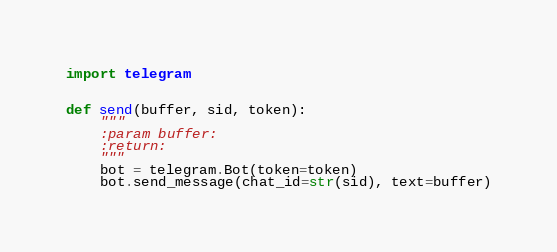<code> <loc_0><loc_0><loc_500><loc_500><_Python_>import telegram


def send(buffer, sid, token):
    """
    :param buffer:
    :return:
    """
    bot = telegram.Bot(token=token)
    bot.send_message(chat_id=str(sid), text=buffer)</code> 